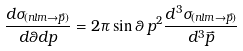<formula> <loc_0><loc_0><loc_500><loc_500>\frac { d \sigma _ { ( n l m \to \vec { p } ) } } { d \theta d p } = 2 \pi \sin \theta \, p ^ { 2 } \frac { d ^ { 3 } \sigma _ { ( n l m \to \vec { p } ) } } { d ^ { 3 } \vec { p } }</formula> 